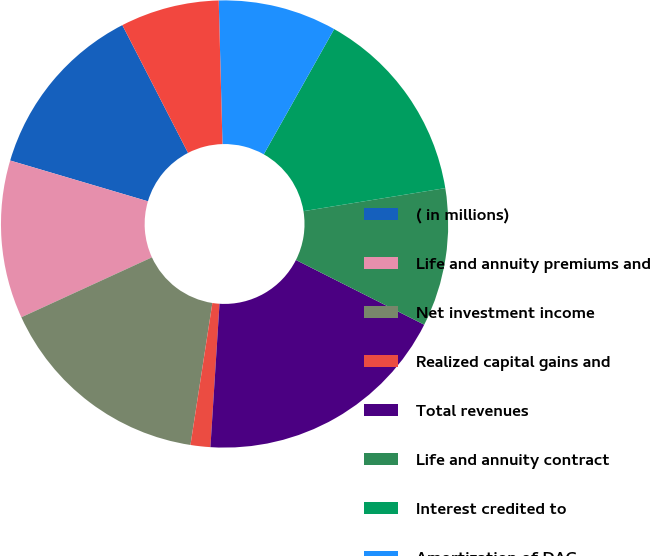Convert chart to OTSL. <chart><loc_0><loc_0><loc_500><loc_500><pie_chart><fcel>( in millions)<fcel>Life and annuity premiums and<fcel>Net investment income<fcel>Realized capital gains and<fcel>Total revenues<fcel>Life and annuity contract<fcel>Interest credited to<fcel>Amortization of DAC<fcel>Operating costs and expenses<fcel>Restructuring and related<nl><fcel>12.86%<fcel>11.43%<fcel>15.71%<fcel>1.43%<fcel>18.57%<fcel>10.0%<fcel>14.28%<fcel>8.57%<fcel>7.14%<fcel>0.0%<nl></chart> 